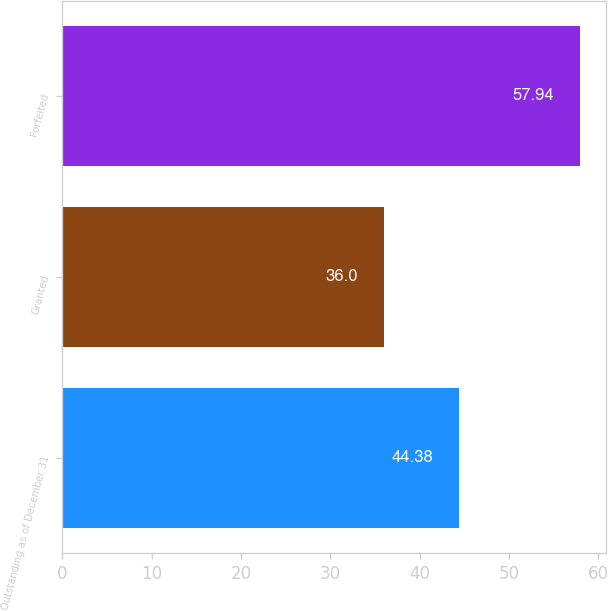Convert chart to OTSL. <chart><loc_0><loc_0><loc_500><loc_500><bar_chart><fcel>Outstanding as of December 31<fcel>Granted<fcel>Forfeited<nl><fcel>44.38<fcel>36<fcel>57.94<nl></chart> 